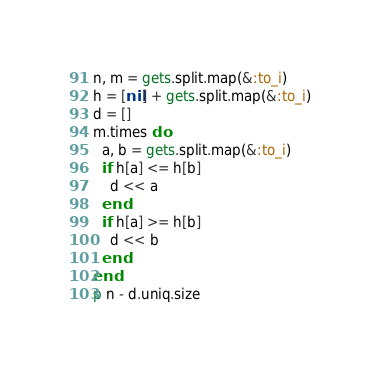<code> <loc_0><loc_0><loc_500><loc_500><_Ruby_>n, m = gets.split.map(&:to_i)
h = [nil] + gets.split.map(&:to_i)
d = []
m.times do
  a, b = gets.split.map(&:to_i)
  if h[a] <= h[b]
    d << a
  end
  if h[a] >= h[b]
    d << b
  end
end
p n - d.uniq.size
</code> 